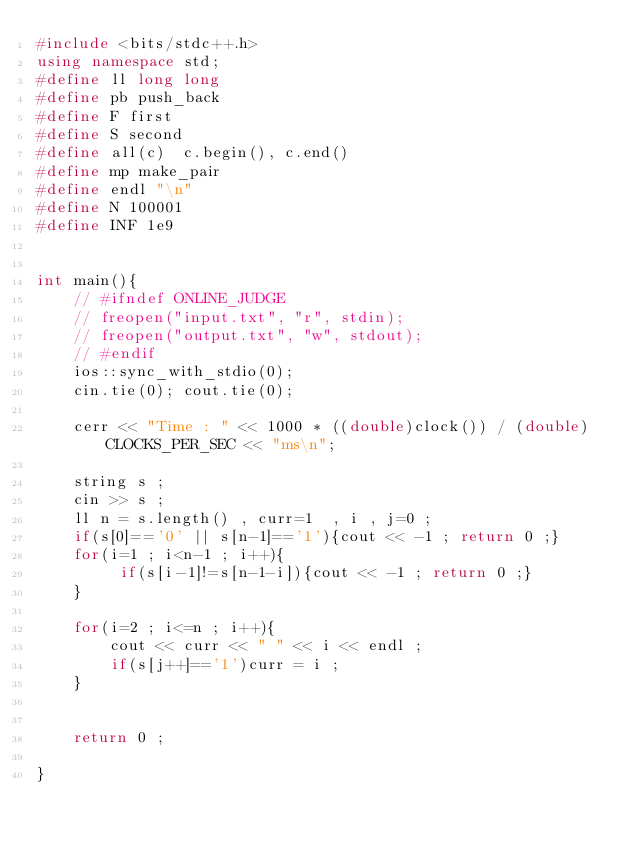Convert code to text. <code><loc_0><loc_0><loc_500><loc_500><_C++_>#include <bits/stdc++.h>
using namespace std;
#define ll long long
#define pb push_back
#define F first
#define S second
#define all(c)  c.begin(), c.end()
#define mp make_pair
#define endl "\n"
#define N 100001
#define INF 1e9


int main(){
    // #ifndef ONLINE_JUDGE
    // freopen("input.txt", "r", stdin);
    // freopen("output.txt", "w", stdout);
    // #endif
    ios::sync_with_stdio(0);
    cin.tie(0); cout.tie(0);
    
    cerr << "Time : " << 1000 * ((double)clock()) / (double)CLOCKS_PER_SEC << "ms\n";
    
    string s ;
    cin >> s ;
    ll n = s.length() , curr=1  , i , j=0 ;
    if(s[0]=='0' || s[n-1]=='1'){cout << -1 ; return 0 ;}
    for(i=1 ; i<n-1 ; i++){
         if(s[i-1]!=s[n-1-i]){cout << -1 ; return 0 ;}
    }
    
    for(i=2 ; i<=n ; i++){
        cout << curr << " " << i << endl ;
        if(s[j++]=='1')curr = i ;
    }


    return 0 ;
    
}
</code> 